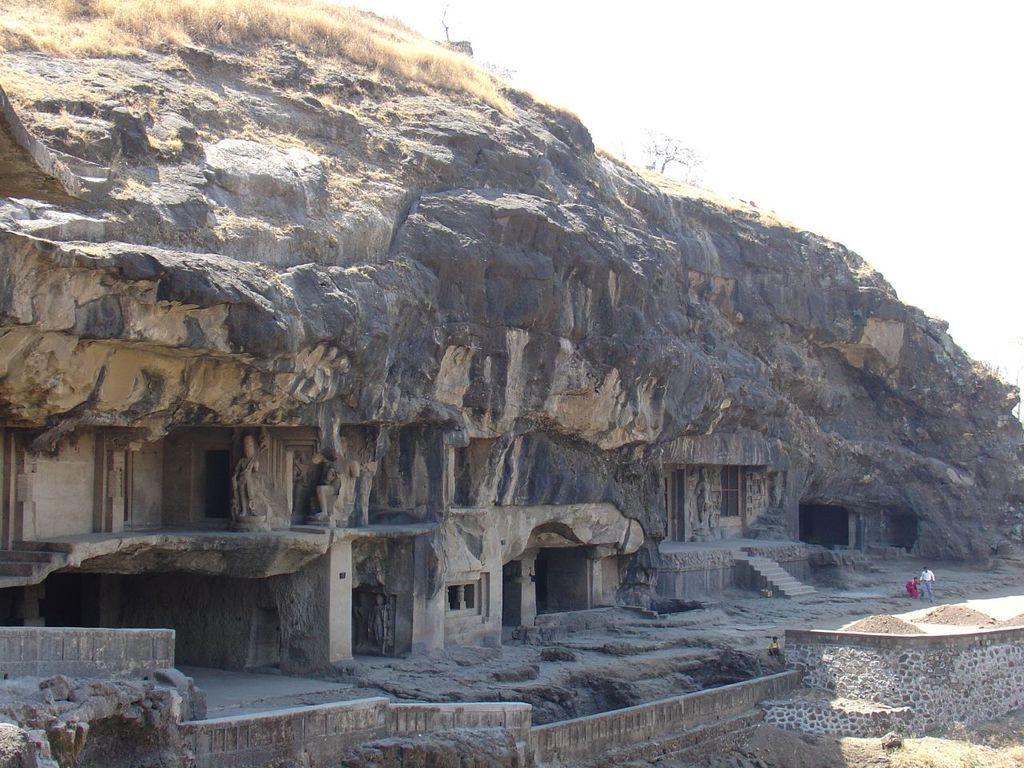How would you summarize this image in a sentence or two? In this image, we can see some caves, stairs. We can also see the ground, a few people, a tree and the sky. We can see some grass. 